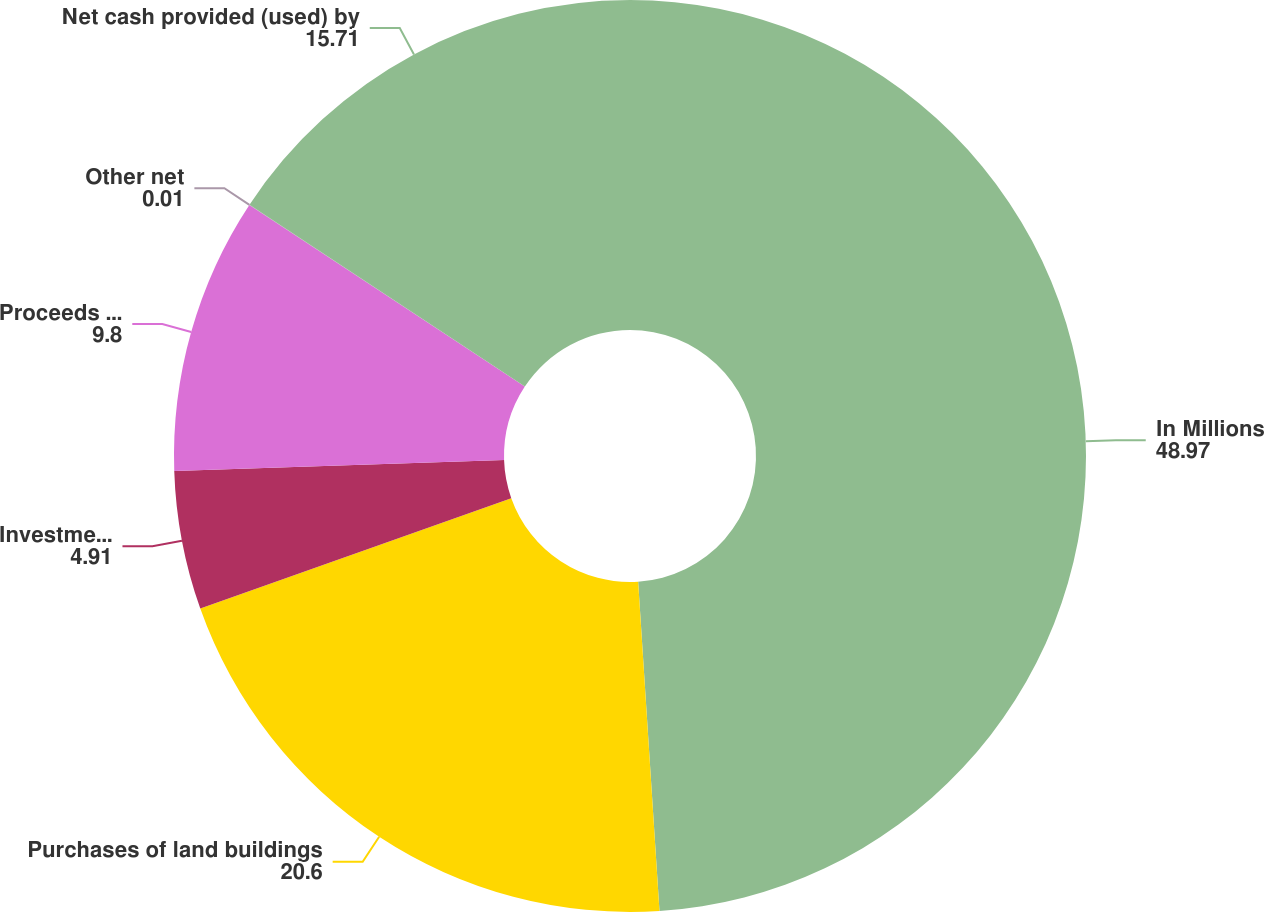Convert chart to OTSL. <chart><loc_0><loc_0><loc_500><loc_500><pie_chart><fcel>In Millions<fcel>Purchases of land buildings<fcel>Investments in affiliates net<fcel>Proceeds from disposal of land<fcel>Other net<fcel>Net cash provided (used) by<nl><fcel>48.97%<fcel>20.6%<fcel>4.91%<fcel>9.8%<fcel>0.01%<fcel>15.71%<nl></chart> 